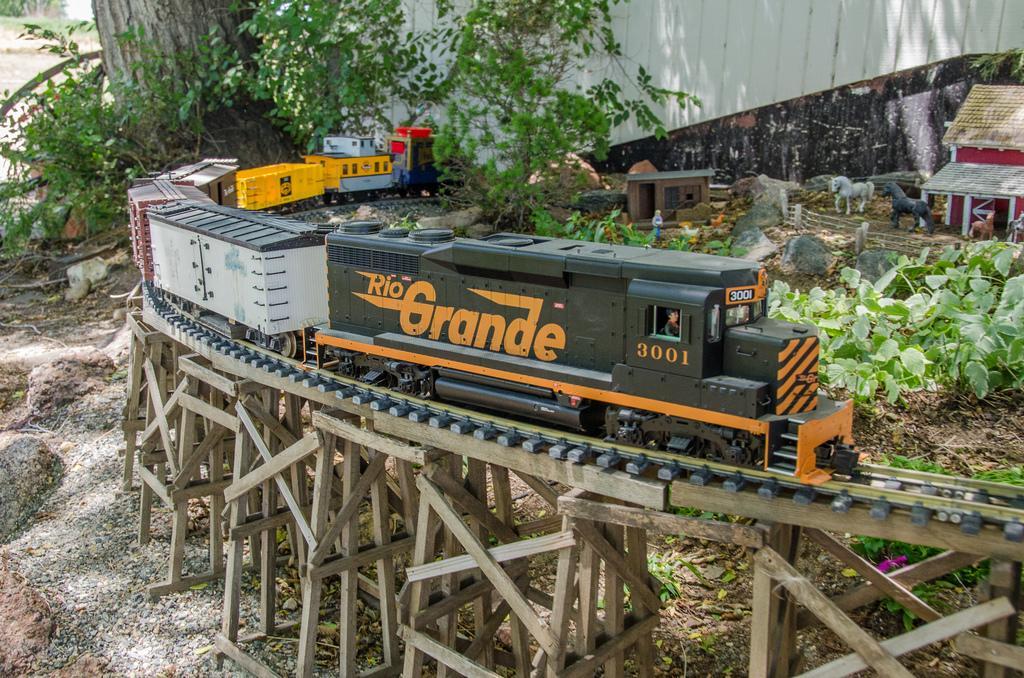Can you describe this image briefly? In the image we can see the toy train on the track. Here we can see a wooden bridge. Here we can see toy horse, house and a toy person. Here we can see stones, leaves and plants. Here we can see a wall and a tree trunk. 